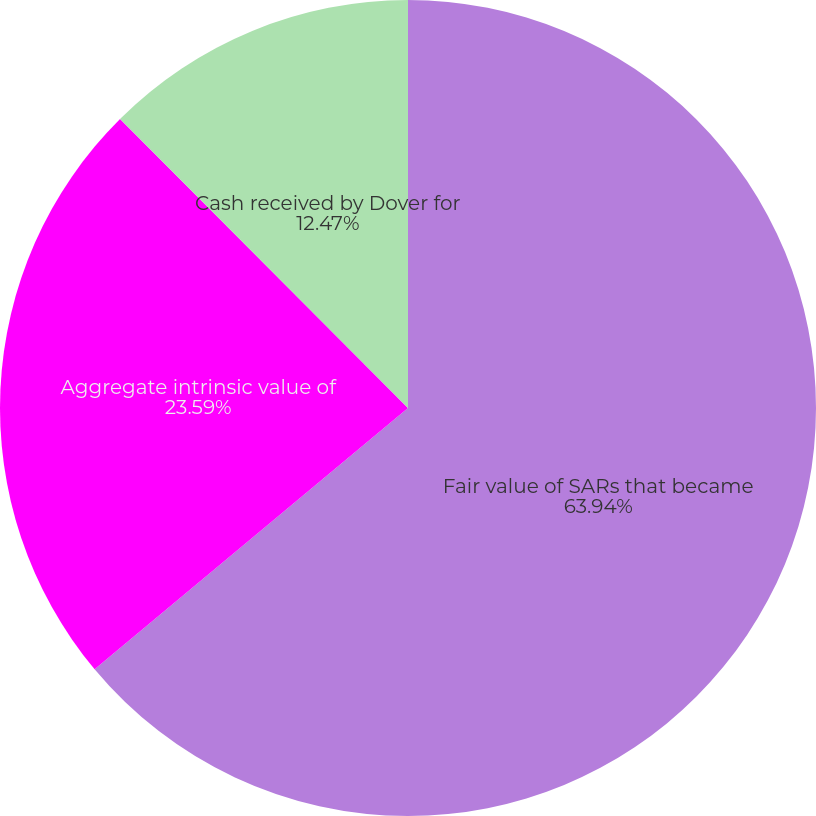<chart> <loc_0><loc_0><loc_500><loc_500><pie_chart><fcel>Fair value of SARs that became<fcel>Aggregate intrinsic value of<fcel>Cash received by Dover for<nl><fcel>63.94%<fcel>23.59%<fcel>12.47%<nl></chart> 